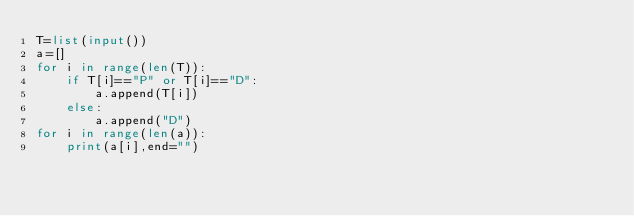<code> <loc_0><loc_0><loc_500><loc_500><_Python_>T=list(input())
a=[]
for i in range(len(T)):
    if T[i]=="P" or T[i]=="D":
        a.append(T[i])
    else:
        a.append("D")
for i in range(len(a)):
    print(a[i],end="")
</code> 